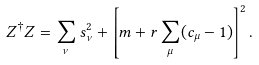Convert formula to latex. <formula><loc_0><loc_0><loc_500><loc_500>Z ^ { \dagger } Z = \sum _ { \nu } s _ { \nu } ^ { 2 } + \left [ m + r \sum _ { \mu } ( c _ { \mu } - 1 ) \right ] ^ { 2 } .</formula> 